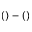Convert formula to latex. <formula><loc_0><loc_0><loc_500><loc_500>( ) - ( )</formula> 